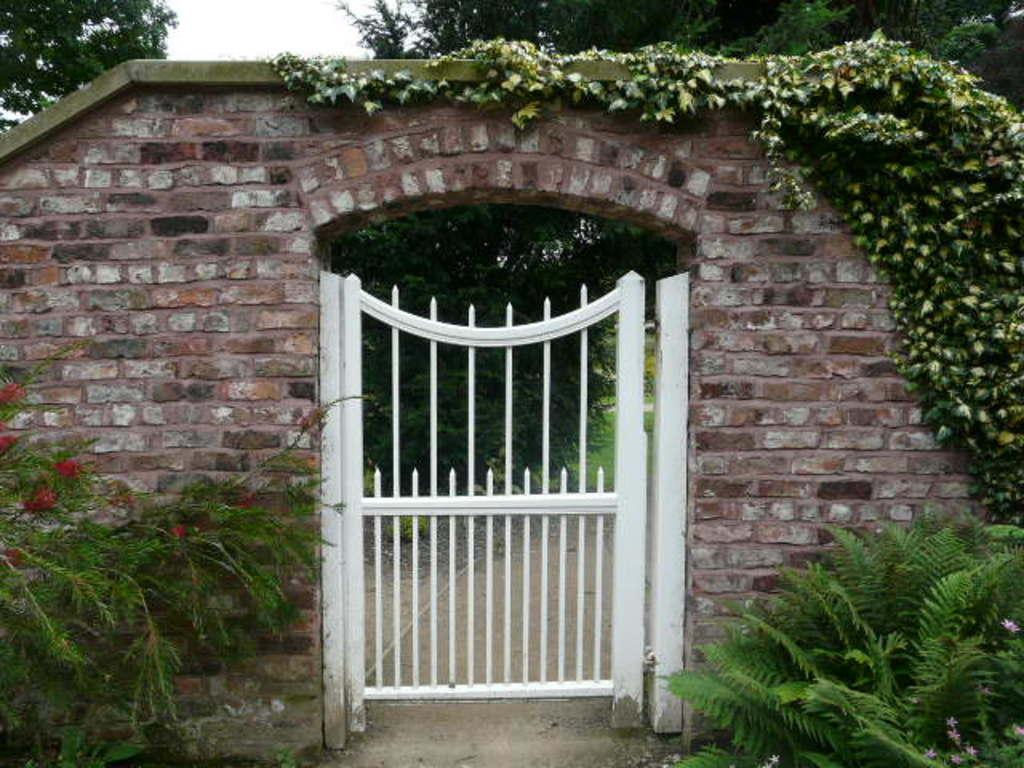What is the color of the gate in the image? The gate in the image is white. What is above the gate in the image? There is an arch above the gate in the image. What can be seen in the surroundings of the gate? There is greenery around the image. How much wealth is depicted in the image? There is no indication of wealth in the image; it features a white gate with an arch and greenery in the surroundings. 